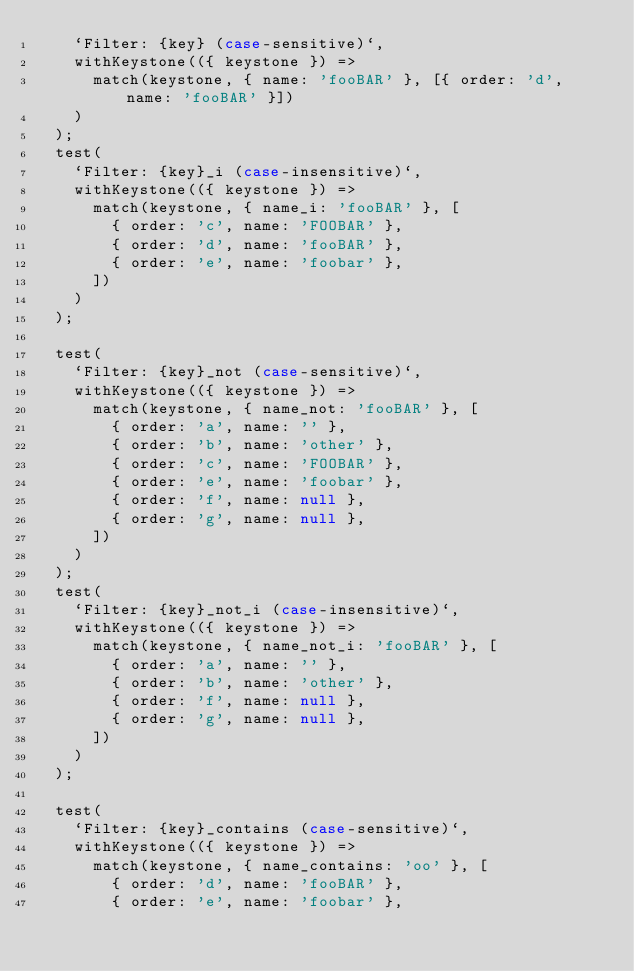<code> <loc_0><loc_0><loc_500><loc_500><_JavaScript_>    `Filter: {key} (case-sensitive)`,
    withKeystone(({ keystone }) =>
      match(keystone, { name: 'fooBAR' }, [{ order: 'd', name: 'fooBAR' }])
    )
  );
  test(
    `Filter: {key}_i (case-insensitive)`,
    withKeystone(({ keystone }) =>
      match(keystone, { name_i: 'fooBAR' }, [
        { order: 'c', name: 'FOOBAR' },
        { order: 'd', name: 'fooBAR' },
        { order: 'e', name: 'foobar' },
      ])
    )
  );

  test(
    `Filter: {key}_not (case-sensitive)`,
    withKeystone(({ keystone }) =>
      match(keystone, { name_not: 'fooBAR' }, [
        { order: 'a', name: '' },
        { order: 'b', name: 'other' },
        { order: 'c', name: 'FOOBAR' },
        { order: 'e', name: 'foobar' },
        { order: 'f', name: null },
        { order: 'g', name: null },
      ])
    )
  );
  test(
    `Filter: {key}_not_i (case-insensitive)`,
    withKeystone(({ keystone }) =>
      match(keystone, { name_not_i: 'fooBAR' }, [
        { order: 'a', name: '' },
        { order: 'b', name: 'other' },
        { order: 'f', name: null },
        { order: 'g', name: null },
      ])
    )
  );

  test(
    `Filter: {key}_contains (case-sensitive)`,
    withKeystone(({ keystone }) =>
      match(keystone, { name_contains: 'oo' }, [
        { order: 'd', name: 'fooBAR' },
        { order: 'e', name: 'foobar' },</code> 